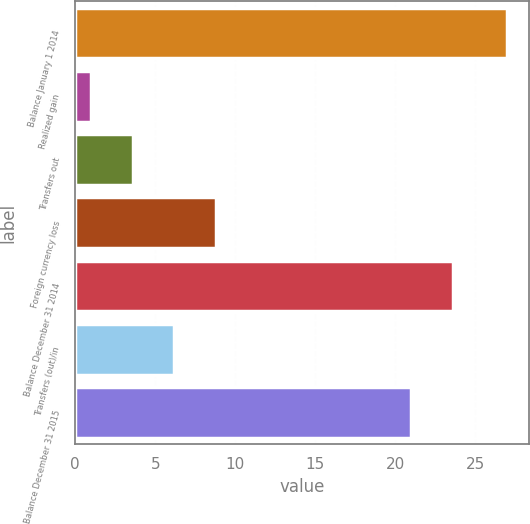Convert chart to OTSL. <chart><loc_0><loc_0><loc_500><loc_500><bar_chart><fcel>Balance January 1 2014<fcel>Realized gain<fcel>Transfers out<fcel>Foreign currency loss<fcel>Balance December 31 2014<fcel>Transfers (out)/in<fcel>Balance December 31 2015<nl><fcel>27<fcel>1<fcel>3.6<fcel>8.8<fcel>23.6<fcel>6.2<fcel>21<nl></chart> 